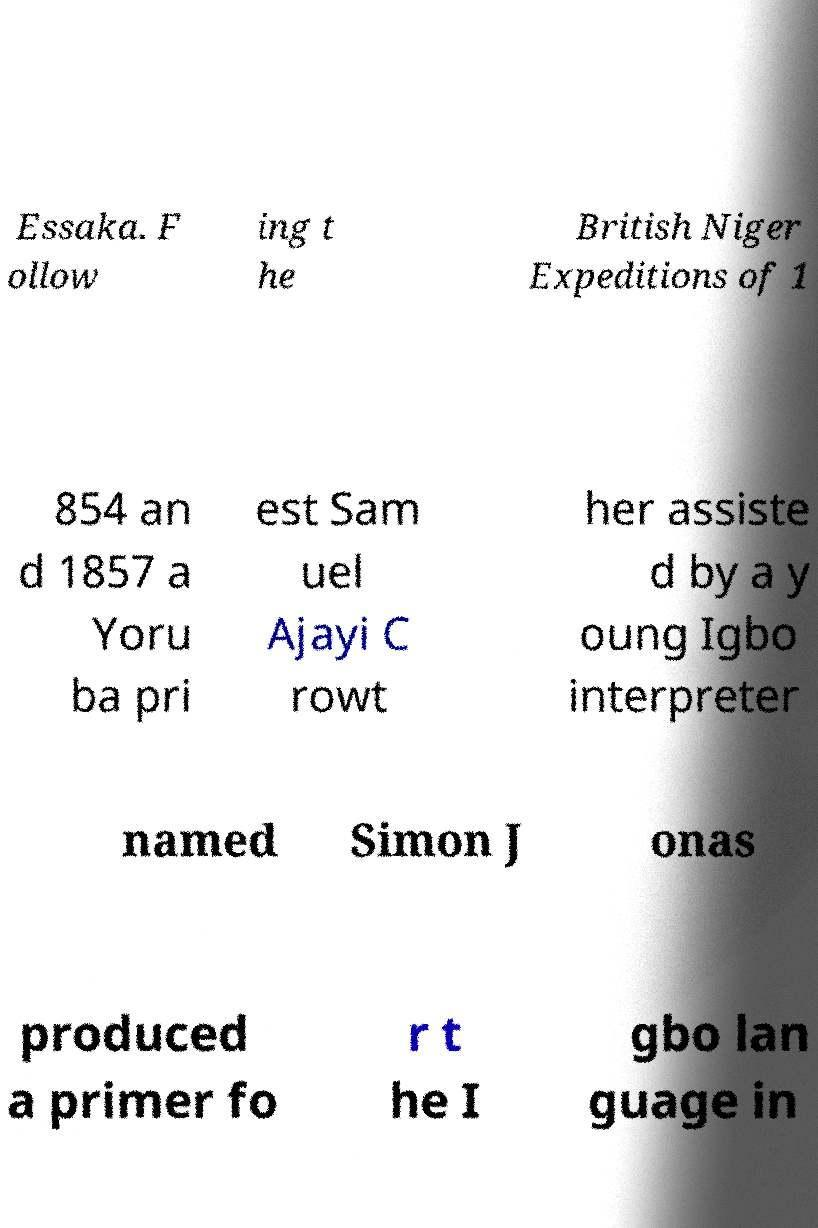I need the written content from this picture converted into text. Can you do that? Essaka. F ollow ing t he British Niger Expeditions of 1 854 an d 1857 a Yoru ba pri est Sam uel Ajayi C rowt her assiste d by a y oung Igbo interpreter named Simon J onas produced a primer fo r t he I gbo lan guage in 